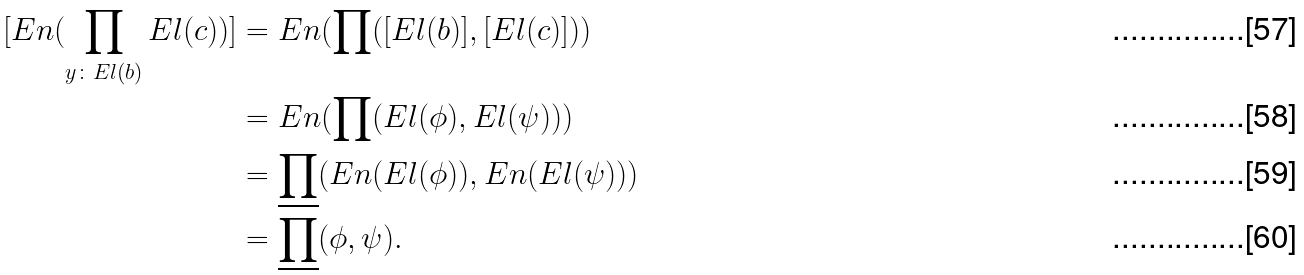<formula> <loc_0><loc_0><loc_500><loc_500>[ E n ( \prod _ { y \colon E l ( b ) } E l ( c ) ) ] & = E n ( \prod ( [ E l ( b ) ] , [ E l ( c ) ] ) ) \\ & = E n ( \prod ( E l ( \phi ) , E l ( \psi ) ) ) \\ & = \underline { \prod } ( E n ( E l ( \phi ) ) , E n ( E l ( \psi ) ) ) \\ & = \underline { \prod } ( \phi , \psi ) .</formula> 